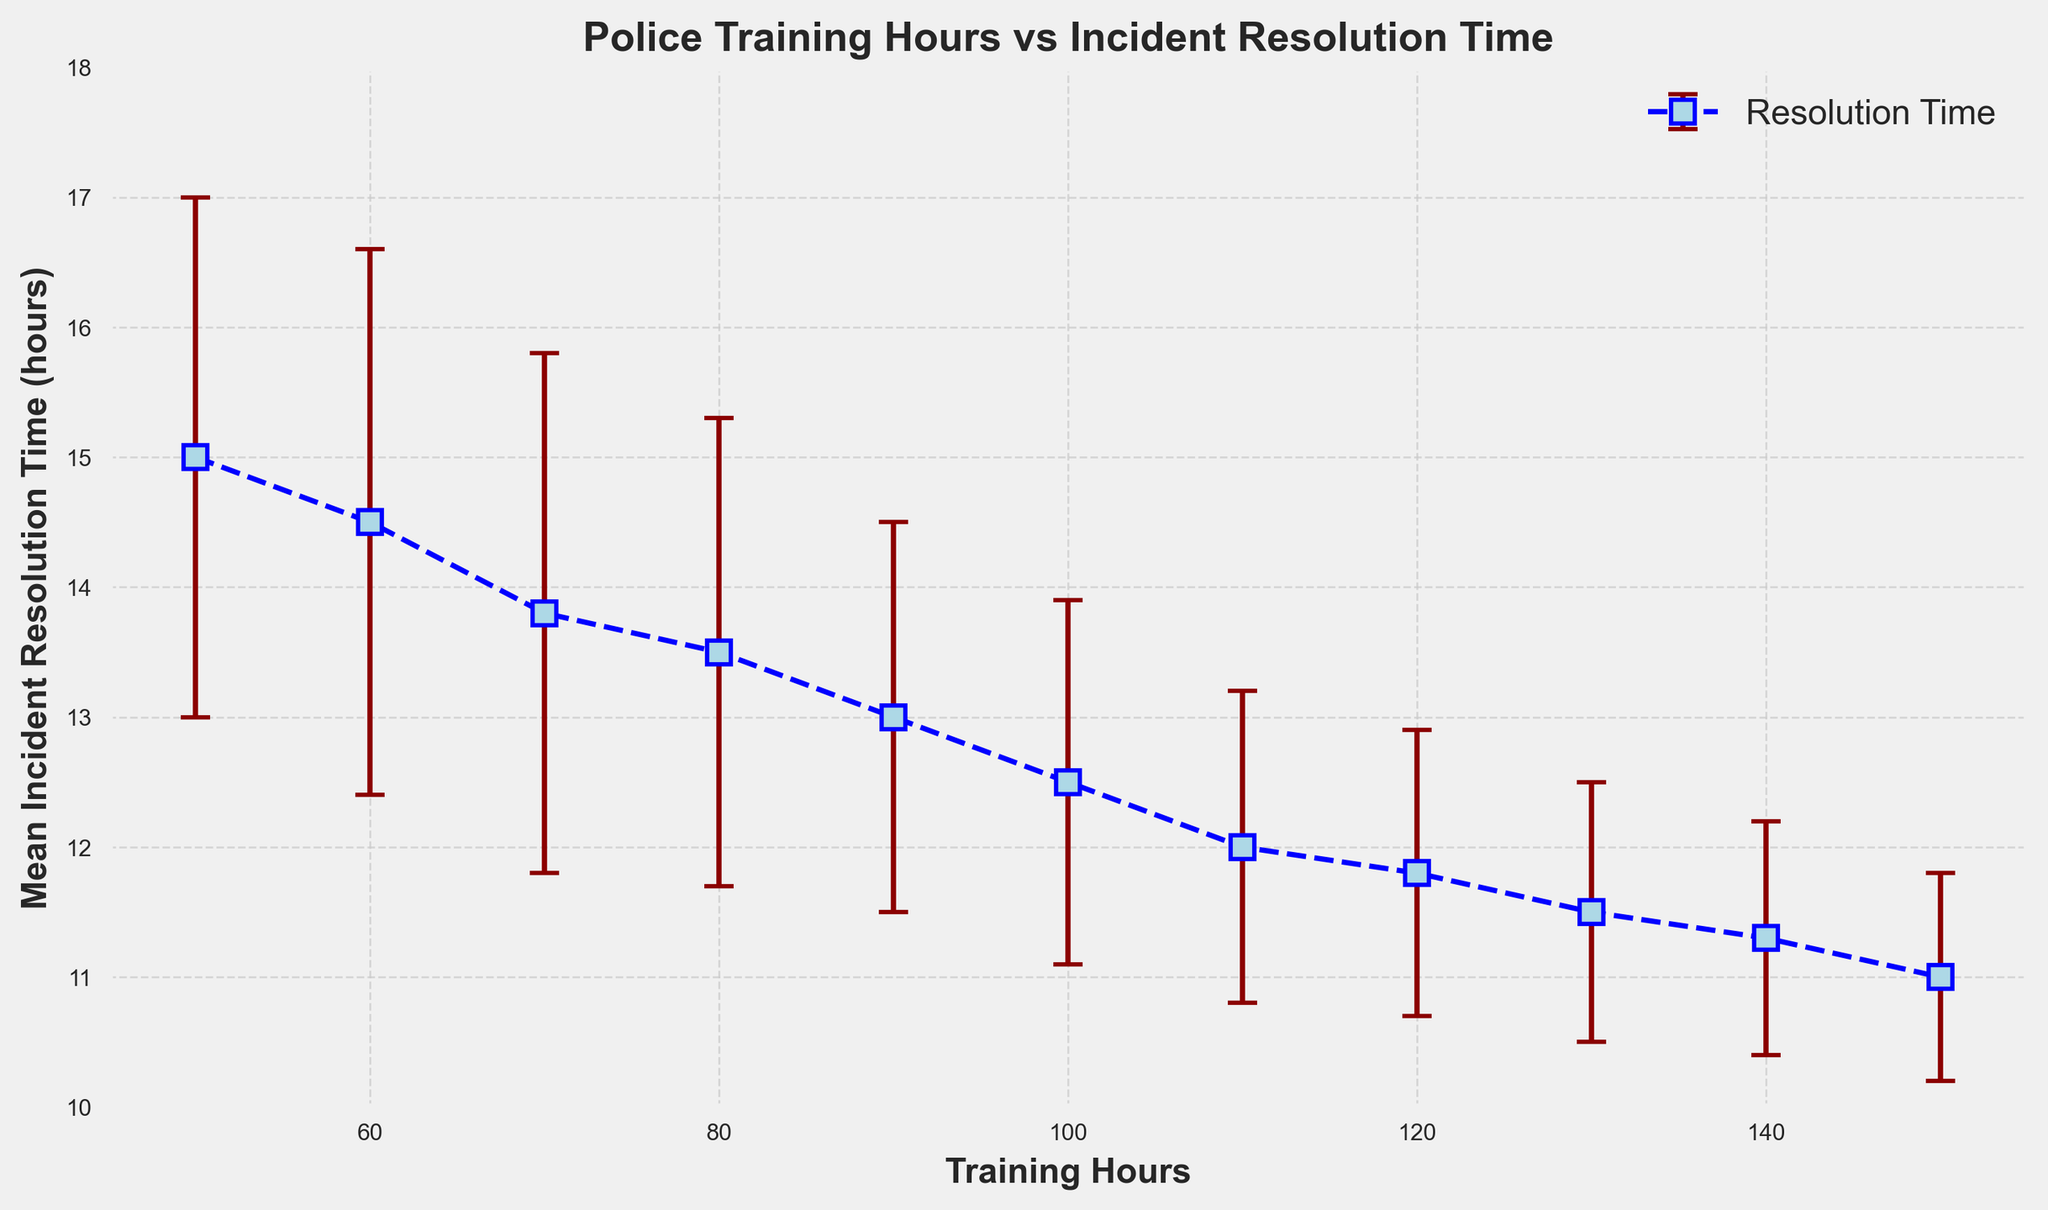How does the mean incident resolution time change as training hours increase? As training hours increase, the mean incident resolution time decreases. This trend suggests that higher training hours are associated with lower mean incident resolution times.
Answer: It decreases What is the mean incident resolution time for 100 training hours, and what is the corresponding standard deviation? At 100 training hours, the mean incident resolution time is observed from the figure. The corresponding point on the plot shows a value of 12.5 hours with an error bar (standard deviation) of 1.4 hours.
Answer: 12.5 hours and 1.4 hours Which training hour value has the lowest mean incident resolution time? By observing the plot, the lowest mean incident resolution time occurs at the highest training hour value presented, which is 150 hours. The mean incident resolution time at this point is 11 hours.
Answer: 150 hours How much does the mean resolution time differ between 80 training hours and 120 training hours? To find the difference, subtract the mean resolution time at 120 hours from the mean resolution time at 80 hours. The mean resolution times at 80 and 120 training hours are 13.5 hours and 11.8 hours, respectively. So, the difference is 13.5 - 11.8 = 1.7 hours.
Answer: 1.7 hours What trend can you detect about the standard deviation of resolution time as training hours increase? Observing the error bars' lengths, the standard deviation of resolution time tends to decrease as training hours increase. This indicates greater consistency in incident resolution times with more training.
Answer: It decreases Is the resolution time at 60 training hours significantly different from that at 90 training hours? Examining the plot, the mean resolution time at 60 training hours is 14.5 hours, and at 90 training hours, it is 13 hours. Additionally, their error bars (2.1 hours and 1.5 hours, respectively) indicate that these values do not significantly overlap, suggesting a noticeable difference.
Answer: Yes What is the difference between the maximum and minimum mean incident resolution times on the plot? The maximum mean incident resolution time is at 50 training hours (15 hours), and the minimum is at 150 training hours (11 hours). The difference is 15 - 11 = 4 hours.
Answer: 4 hours Identify the training hours associated with a mean incident resolution time of 13.8 hours. By locating the point on the plot with a mean incident resolution time of 13.8 hours, it occurs at 70 training hours.
Answer: 70 hours How does the trend in mean incident resolution time change between 50 and 90 training hours compared to between 90 and 150 training hours? Between 50 and 90 training hours, there is a noticeable and consistent decrease in mean incident resolution time. Between 90 and 150 training hours, the decrease continues but at a slightly slower rate. This indicates that training still benefits resolution time but with diminishing returns at higher training hours.
Answer: Decrease continues, but slower at higher hours Compare the error bars' length for 50 and 150 training hours and interpret what it indicates about the resolution time variability. The error bar at 50 training hours is longer (2 hours), while at 150 training hours, it is shorter (0.8 hours). This indicates higher variability in resolution times at 50 training hours compared to 150 training hours.
Answer: Higher variability at 50 hours 